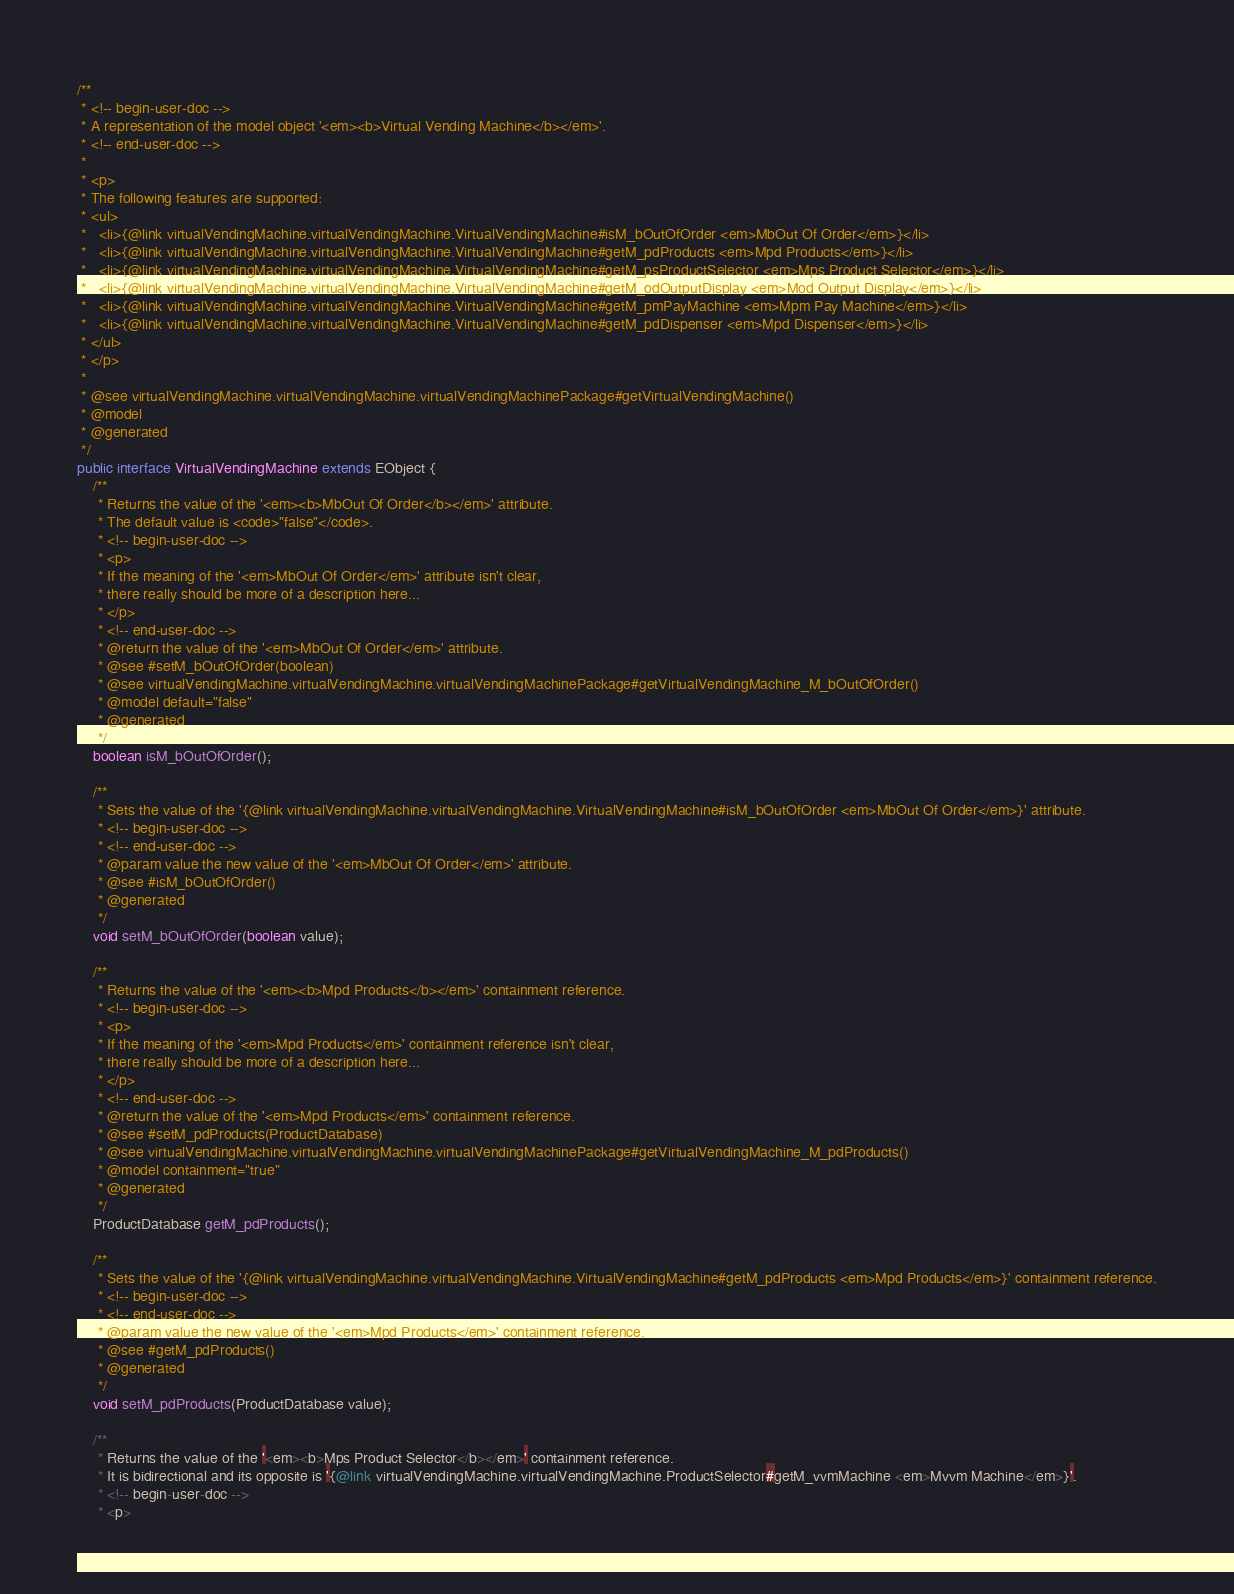Convert code to text. <code><loc_0><loc_0><loc_500><loc_500><_Java_>
/**
 * <!-- begin-user-doc -->
 * A representation of the model object '<em><b>Virtual Vending Machine</b></em>'.
 * <!-- end-user-doc -->
 *
 * <p>
 * The following features are supported:
 * <ul>
 *   <li>{@link virtualVendingMachine.virtualVendingMachine.VirtualVendingMachine#isM_bOutOfOrder <em>MbOut Of Order</em>}</li>
 *   <li>{@link virtualVendingMachine.virtualVendingMachine.VirtualVendingMachine#getM_pdProducts <em>Mpd Products</em>}</li>
 *   <li>{@link virtualVendingMachine.virtualVendingMachine.VirtualVendingMachine#getM_psProductSelector <em>Mps Product Selector</em>}</li>
 *   <li>{@link virtualVendingMachine.virtualVendingMachine.VirtualVendingMachine#getM_odOutputDisplay <em>Mod Output Display</em>}</li>
 *   <li>{@link virtualVendingMachine.virtualVendingMachine.VirtualVendingMachine#getM_pmPayMachine <em>Mpm Pay Machine</em>}</li>
 *   <li>{@link virtualVendingMachine.virtualVendingMachine.VirtualVendingMachine#getM_pdDispenser <em>Mpd Dispenser</em>}</li>
 * </ul>
 * </p>
 *
 * @see virtualVendingMachine.virtualVendingMachine.virtualVendingMachinePackage#getVirtualVendingMachine()
 * @model
 * @generated
 */
public interface VirtualVendingMachine extends EObject {
	/**
	 * Returns the value of the '<em><b>MbOut Of Order</b></em>' attribute.
	 * The default value is <code>"false"</code>.
	 * <!-- begin-user-doc -->
	 * <p>
	 * If the meaning of the '<em>MbOut Of Order</em>' attribute isn't clear,
	 * there really should be more of a description here...
	 * </p>
	 * <!-- end-user-doc -->
	 * @return the value of the '<em>MbOut Of Order</em>' attribute.
	 * @see #setM_bOutOfOrder(boolean)
	 * @see virtualVendingMachine.virtualVendingMachine.virtualVendingMachinePackage#getVirtualVendingMachine_M_bOutOfOrder()
	 * @model default="false"
	 * @generated
	 */
	boolean isM_bOutOfOrder();

	/**
	 * Sets the value of the '{@link virtualVendingMachine.virtualVendingMachine.VirtualVendingMachine#isM_bOutOfOrder <em>MbOut Of Order</em>}' attribute.
	 * <!-- begin-user-doc -->
	 * <!-- end-user-doc -->
	 * @param value the new value of the '<em>MbOut Of Order</em>' attribute.
	 * @see #isM_bOutOfOrder()
	 * @generated
	 */
	void setM_bOutOfOrder(boolean value);

	/**
	 * Returns the value of the '<em><b>Mpd Products</b></em>' containment reference.
	 * <!-- begin-user-doc -->
	 * <p>
	 * If the meaning of the '<em>Mpd Products</em>' containment reference isn't clear,
	 * there really should be more of a description here...
	 * </p>
	 * <!-- end-user-doc -->
	 * @return the value of the '<em>Mpd Products</em>' containment reference.
	 * @see #setM_pdProducts(ProductDatabase)
	 * @see virtualVendingMachine.virtualVendingMachine.virtualVendingMachinePackage#getVirtualVendingMachine_M_pdProducts()
	 * @model containment="true"
	 * @generated
	 */
	ProductDatabase getM_pdProducts();

	/**
	 * Sets the value of the '{@link virtualVendingMachine.virtualVendingMachine.VirtualVendingMachine#getM_pdProducts <em>Mpd Products</em>}' containment reference.
	 * <!-- begin-user-doc -->
	 * <!-- end-user-doc -->
	 * @param value the new value of the '<em>Mpd Products</em>' containment reference.
	 * @see #getM_pdProducts()
	 * @generated
	 */
	void setM_pdProducts(ProductDatabase value);

	/**
	 * Returns the value of the '<em><b>Mps Product Selector</b></em>' containment reference.
	 * It is bidirectional and its opposite is '{@link virtualVendingMachine.virtualVendingMachine.ProductSelector#getM_vvmMachine <em>Mvvm Machine</em>}'.
	 * <!-- begin-user-doc -->
	 * <p></code> 